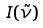Convert formula to latex. <formula><loc_0><loc_0><loc_500><loc_500>I ( \tilde { \nu } )</formula> 